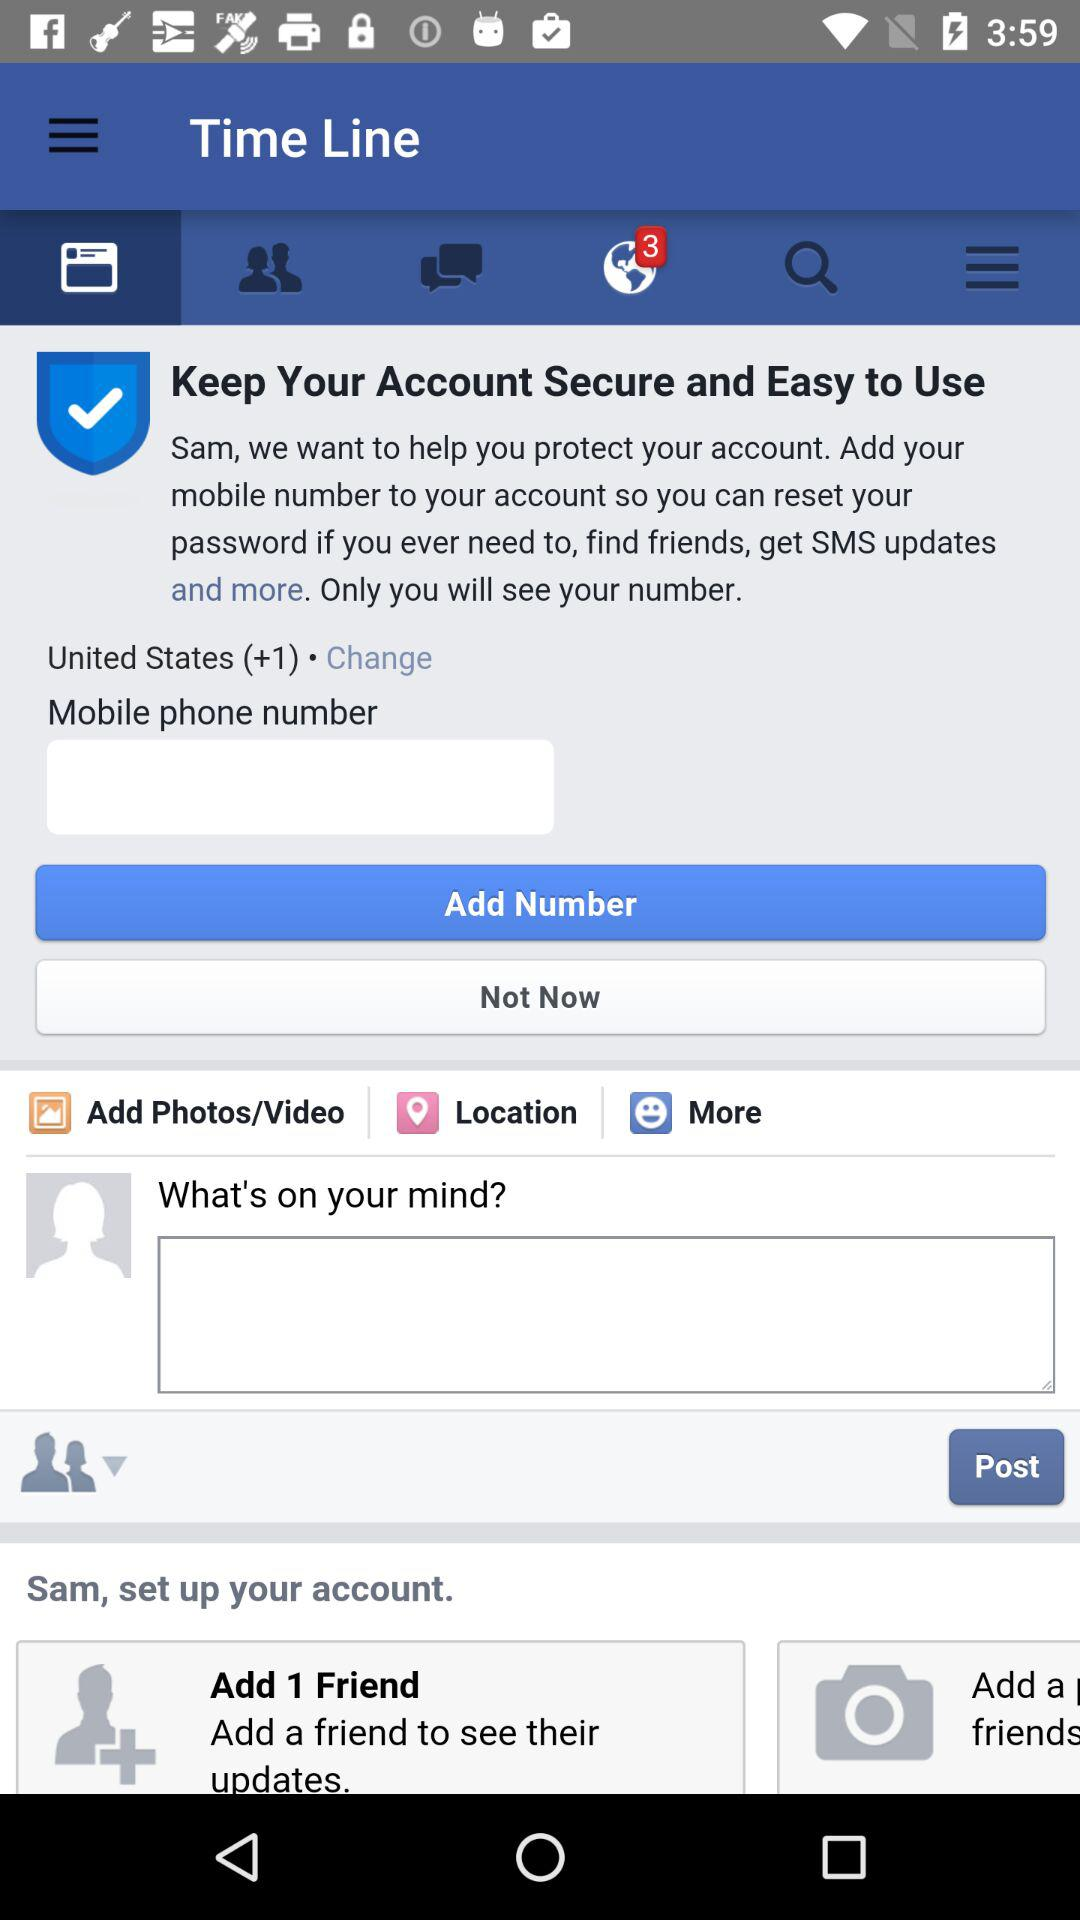What is the mobile number?
When the provided information is insufficient, respond with <no answer>. <no answer> 